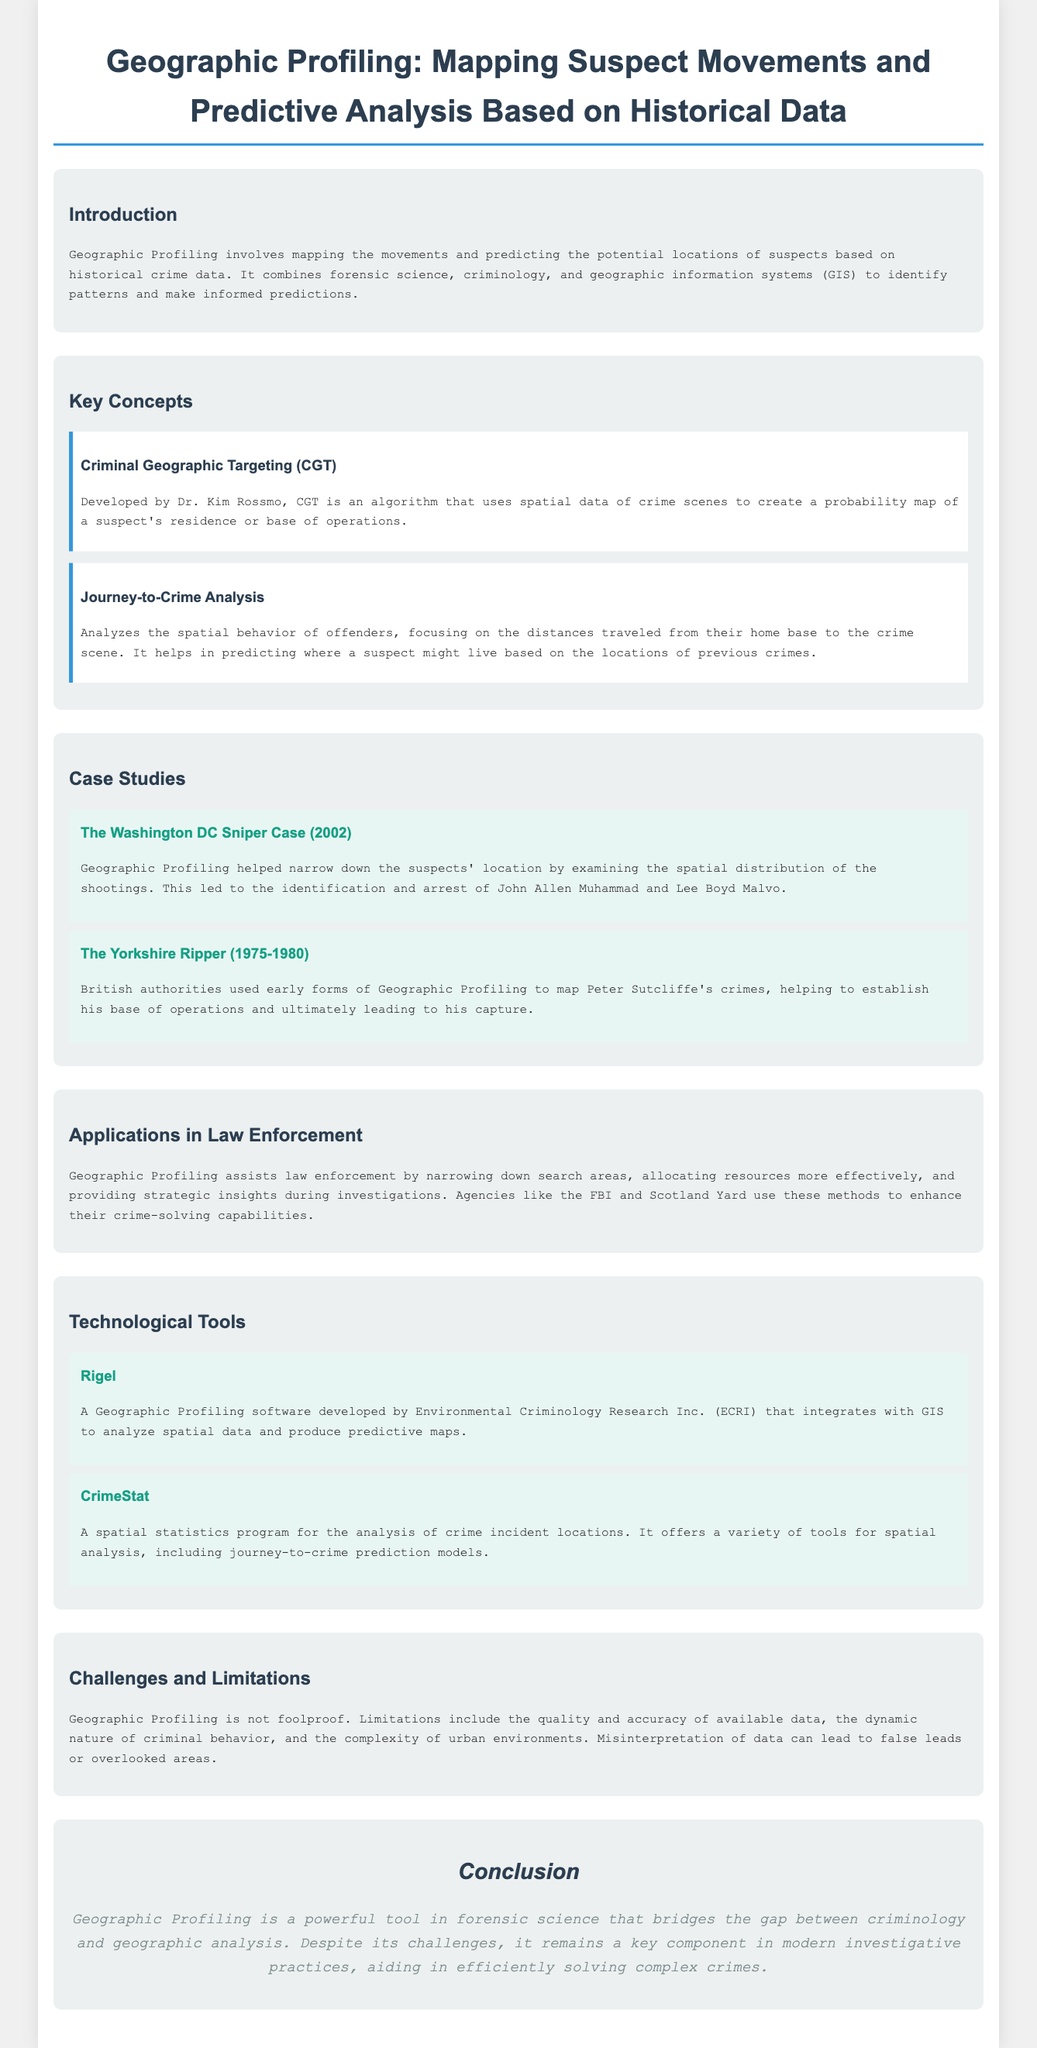What is Geographic Profiling? Geographic Profiling involves mapping the movements and predicting the potential locations of suspects based on historical crime data.
Answer: mapping movements and predicting suspect locations Who developed Criminal Geographic Targeting? Criminal Geographic Targeting was developed by Dr. Kim Rossmo as mentioned in the document.
Answer: Dr. Kim Rossmo What year was the Washington DC Sniper case? The Washington DC Sniper case occurred in 2002, as stated in the case study section.
Answer: 2002 What software integrates with GIS for Geographic Profiling? Rigel is a Geographic Profiling software that integrates with GIS as indicated in the document.
Answer: Rigel What is a key limitation of Geographic Profiling? One key limitation is the quality and accuracy of available data, mentioned in the challenges section.
Answer: quality and accuracy of available data How does Geographic Profiling assist law enforcement? It assists law enforcement by narrowing down search areas, as outlined in the applications section.
Answer: narrowing down search areas What type of analysis focuses on distances traveled to crime scenes? Journey-to-Crime Analysis focuses on the distances traveled from suspects' home bases to crime scenes.
Answer: Journey-to-Crime Analysis What colors are used in the section headers of the document? The section headers use the color #2c3e50, as reflected in the styling of the document.
Answer: #2c3e50 